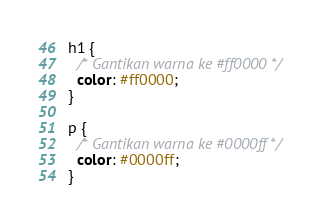<code> <loc_0><loc_0><loc_500><loc_500><_CSS_>h1 {
  /* Gantikan warna ke #ff0000 */
  color: #ff0000;
}

p {
  /* Gantikan warna ke #0000ff */
  color: #0000ff;
}</code> 